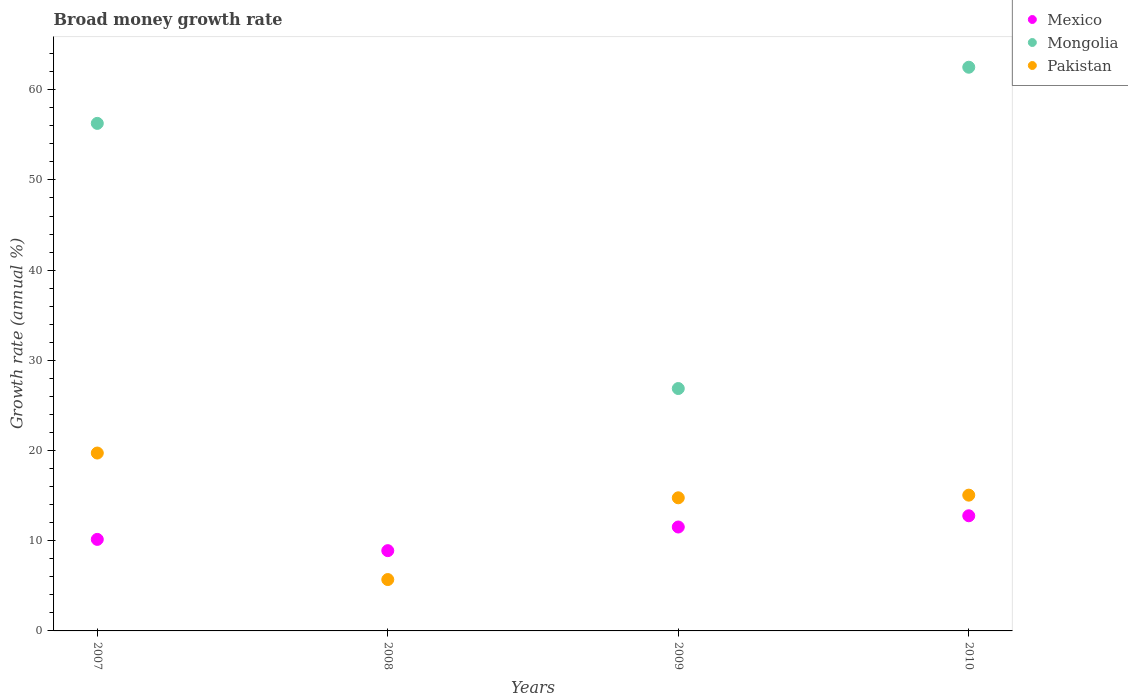How many different coloured dotlines are there?
Offer a terse response. 3. Is the number of dotlines equal to the number of legend labels?
Offer a very short reply. No. What is the growth rate in Pakistan in 2010?
Your answer should be very brief. 15.05. Across all years, what is the maximum growth rate in Pakistan?
Your response must be concise. 19.72. Across all years, what is the minimum growth rate in Pakistan?
Offer a very short reply. 5.69. In which year was the growth rate in Mongolia maximum?
Offer a very short reply. 2010. What is the total growth rate in Mexico in the graph?
Provide a succinct answer. 43.33. What is the difference between the growth rate in Pakistan in 2007 and that in 2008?
Your response must be concise. 14.03. What is the difference between the growth rate in Pakistan in 2010 and the growth rate in Mongolia in 2009?
Offer a very short reply. -11.82. What is the average growth rate in Mongolia per year?
Your answer should be very brief. 36.41. In the year 2010, what is the difference between the growth rate in Mexico and growth rate in Mongolia?
Offer a very short reply. -49.73. What is the ratio of the growth rate in Mongolia in 2009 to that in 2010?
Make the answer very short. 0.43. Is the growth rate in Mexico in 2007 less than that in 2009?
Your answer should be compact. Yes. What is the difference between the highest and the second highest growth rate in Mexico?
Keep it short and to the point. 1.25. What is the difference between the highest and the lowest growth rate in Mongolia?
Provide a succinct answer. 62.5. In how many years, is the growth rate in Mexico greater than the average growth rate in Mexico taken over all years?
Your answer should be compact. 2. Is it the case that in every year, the sum of the growth rate in Mexico and growth rate in Pakistan  is greater than the growth rate in Mongolia?
Offer a very short reply. No. Does the growth rate in Mexico monotonically increase over the years?
Give a very brief answer. No. How many dotlines are there?
Make the answer very short. 3. What is the difference between two consecutive major ticks on the Y-axis?
Your answer should be very brief. 10. Are the values on the major ticks of Y-axis written in scientific E-notation?
Make the answer very short. No. Does the graph contain grids?
Provide a short and direct response. No. How are the legend labels stacked?
Provide a succinct answer. Vertical. What is the title of the graph?
Your answer should be compact. Broad money growth rate. Does "Low & middle income" appear as one of the legend labels in the graph?
Offer a very short reply. No. What is the label or title of the Y-axis?
Ensure brevity in your answer.  Growth rate (annual %). What is the Growth rate (annual %) of Mexico in 2007?
Provide a short and direct response. 10.15. What is the Growth rate (annual %) in Mongolia in 2007?
Give a very brief answer. 56.27. What is the Growth rate (annual %) of Pakistan in 2007?
Make the answer very short. 19.72. What is the Growth rate (annual %) in Mexico in 2008?
Your answer should be very brief. 8.9. What is the Growth rate (annual %) of Mongolia in 2008?
Provide a succinct answer. 0. What is the Growth rate (annual %) in Pakistan in 2008?
Your answer should be very brief. 5.69. What is the Growth rate (annual %) of Mexico in 2009?
Provide a succinct answer. 11.52. What is the Growth rate (annual %) of Mongolia in 2009?
Offer a very short reply. 26.87. What is the Growth rate (annual %) of Pakistan in 2009?
Your answer should be compact. 14.76. What is the Growth rate (annual %) in Mexico in 2010?
Provide a succinct answer. 12.77. What is the Growth rate (annual %) of Mongolia in 2010?
Provide a short and direct response. 62.5. What is the Growth rate (annual %) in Pakistan in 2010?
Offer a very short reply. 15.05. Across all years, what is the maximum Growth rate (annual %) of Mexico?
Your response must be concise. 12.77. Across all years, what is the maximum Growth rate (annual %) of Mongolia?
Provide a succinct answer. 62.5. Across all years, what is the maximum Growth rate (annual %) in Pakistan?
Give a very brief answer. 19.72. Across all years, what is the minimum Growth rate (annual %) in Mexico?
Keep it short and to the point. 8.9. Across all years, what is the minimum Growth rate (annual %) of Pakistan?
Provide a succinct answer. 5.69. What is the total Growth rate (annual %) in Mexico in the graph?
Keep it short and to the point. 43.33. What is the total Growth rate (annual %) of Mongolia in the graph?
Ensure brevity in your answer.  145.64. What is the total Growth rate (annual %) in Pakistan in the graph?
Your answer should be very brief. 55.23. What is the difference between the Growth rate (annual %) in Mexico in 2007 and that in 2008?
Keep it short and to the point. 1.25. What is the difference between the Growth rate (annual %) in Pakistan in 2007 and that in 2008?
Your answer should be compact. 14.03. What is the difference between the Growth rate (annual %) of Mexico in 2007 and that in 2009?
Keep it short and to the point. -1.37. What is the difference between the Growth rate (annual %) in Mongolia in 2007 and that in 2009?
Your answer should be compact. 29.4. What is the difference between the Growth rate (annual %) of Pakistan in 2007 and that in 2009?
Make the answer very short. 4.96. What is the difference between the Growth rate (annual %) of Mexico in 2007 and that in 2010?
Provide a short and direct response. -2.62. What is the difference between the Growth rate (annual %) in Mongolia in 2007 and that in 2010?
Offer a very short reply. -6.23. What is the difference between the Growth rate (annual %) of Pakistan in 2007 and that in 2010?
Offer a terse response. 4.67. What is the difference between the Growth rate (annual %) in Mexico in 2008 and that in 2009?
Give a very brief answer. -2.62. What is the difference between the Growth rate (annual %) of Pakistan in 2008 and that in 2009?
Give a very brief answer. -9.06. What is the difference between the Growth rate (annual %) in Mexico in 2008 and that in 2010?
Your response must be concise. -3.87. What is the difference between the Growth rate (annual %) in Pakistan in 2008 and that in 2010?
Ensure brevity in your answer.  -9.36. What is the difference between the Growth rate (annual %) in Mexico in 2009 and that in 2010?
Offer a terse response. -1.25. What is the difference between the Growth rate (annual %) of Mongolia in 2009 and that in 2010?
Provide a succinct answer. -35.62. What is the difference between the Growth rate (annual %) of Pakistan in 2009 and that in 2010?
Provide a short and direct response. -0.29. What is the difference between the Growth rate (annual %) of Mexico in 2007 and the Growth rate (annual %) of Pakistan in 2008?
Your response must be concise. 4.45. What is the difference between the Growth rate (annual %) of Mongolia in 2007 and the Growth rate (annual %) of Pakistan in 2008?
Your answer should be very brief. 50.58. What is the difference between the Growth rate (annual %) in Mexico in 2007 and the Growth rate (annual %) in Mongolia in 2009?
Provide a succinct answer. -16.73. What is the difference between the Growth rate (annual %) of Mexico in 2007 and the Growth rate (annual %) of Pakistan in 2009?
Keep it short and to the point. -4.61. What is the difference between the Growth rate (annual %) of Mongolia in 2007 and the Growth rate (annual %) of Pakistan in 2009?
Your answer should be very brief. 41.51. What is the difference between the Growth rate (annual %) in Mexico in 2007 and the Growth rate (annual %) in Mongolia in 2010?
Your answer should be compact. -52.35. What is the difference between the Growth rate (annual %) of Mexico in 2007 and the Growth rate (annual %) of Pakistan in 2010?
Provide a succinct answer. -4.91. What is the difference between the Growth rate (annual %) of Mongolia in 2007 and the Growth rate (annual %) of Pakistan in 2010?
Your answer should be compact. 41.22. What is the difference between the Growth rate (annual %) of Mexico in 2008 and the Growth rate (annual %) of Mongolia in 2009?
Give a very brief answer. -17.97. What is the difference between the Growth rate (annual %) in Mexico in 2008 and the Growth rate (annual %) in Pakistan in 2009?
Ensure brevity in your answer.  -5.86. What is the difference between the Growth rate (annual %) of Mexico in 2008 and the Growth rate (annual %) of Mongolia in 2010?
Keep it short and to the point. -53.6. What is the difference between the Growth rate (annual %) in Mexico in 2008 and the Growth rate (annual %) in Pakistan in 2010?
Provide a short and direct response. -6.15. What is the difference between the Growth rate (annual %) in Mexico in 2009 and the Growth rate (annual %) in Mongolia in 2010?
Ensure brevity in your answer.  -50.98. What is the difference between the Growth rate (annual %) of Mexico in 2009 and the Growth rate (annual %) of Pakistan in 2010?
Offer a very short reply. -3.53. What is the difference between the Growth rate (annual %) in Mongolia in 2009 and the Growth rate (annual %) in Pakistan in 2010?
Your answer should be compact. 11.82. What is the average Growth rate (annual %) in Mexico per year?
Provide a succinct answer. 10.83. What is the average Growth rate (annual %) in Mongolia per year?
Provide a succinct answer. 36.41. What is the average Growth rate (annual %) in Pakistan per year?
Give a very brief answer. 13.81. In the year 2007, what is the difference between the Growth rate (annual %) of Mexico and Growth rate (annual %) of Mongolia?
Ensure brevity in your answer.  -46.12. In the year 2007, what is the difference between the Growth rate (annual %) in Mexico and Growth rate (annual %) in Pakistan?
Your response must be concise. -9.57. In the year 2007, what is the difference between the Growth rate (annual %) of Mongolia and Growth rate (annual %) of Pakistan?
Offer a very short reply. 36.55. In the year 2008, what is the difference between the Growth rate (annual %) in Mexico and Growth rate (annual %) in Pakistan?
Offer a very short reply. 3.2. In the year 2009, what is the difference between the Growth rate (annual %) of Mexico and Growth rate (annual %) of Mongolia?
Your response must be concise. -15.35. In the year 2009, what is the difference between the Growth rate (annual %) of Mexico and Growth rate (annual %) of Pakistan?
Ensure brevity in your answer.  -3.24. In the year 2009, what is the difference between the Growth rate (annual %) in Mongolia and Growth rate (annual %) in Pakistan?
Give a very brief answer. 12.11. In the year 2010, what is the difference between the Growth rate (annual %) of Mexico and Growth rate (annual %) of Mongolia?
Your answer should be compact. -49.73. In the year 2010, what is the difference between the Growth rate (annual %) of Mexico and Growth rate (annual %) of Pakistan?
Your answer should be very brief. -2.29. In the year 2010, what is the difference between the Growth rate (annual %) of Mongolia and Growth rate (annual %) of Pakistan?
Offer a terse response. 47.44. What is the ratio of the Growth rate (annual %) in Mexico in 2007 to that in 2008?
Your answer should be very brief. 1.14. What is the ratio of the Growth rate (annual %) in Pakistan in 2007 to that in 2008?
Offer a very short reply. 3.46. What is the ratio of the Growth rate (annual %) in Mexico in 2007 to that in 2009?
Keep it short and to the point. 0.88. What is the ratio of the Growth rate (annual %) of Mongolia in 2007 to that in 2009?
Provide a succinct answer. 2.09. What is the ratio of the Growth rate (annual %) of Pakistan in 2007 to that in 2009?
Your answer should be very brief. 1.34. What is the ratio of the Growth rate (annual %) of Mexico in 2007 to that in 2010?
Your answer should be very brief. 0.79. What is the ratio of the Growth rate (annual %) in Mongolia in 2007 to that in 2010?
Offer a very short reply. 0.9. What is the ratio of the Growth rate (annual %) in Pakistan in 2007 to that in 2010?
Offer a terse response. 1.31. What is the ratio of the Growth rate (annual %) of Mexico in 2008 to that in 2009?
Provide a short and direct response. 0.77. What is the ratio of the Growth rate (annual %) in Pakistan in 2008 to that in 2009?
Offer a very short reply. 0.39. What is the ratio of the Growth rate (annual %) in Mexico in 2008 to that in 2010?
Ensure brevity in your answer.  0.7. What is the ratio of the Growth rate (annual %) of Pakistan in 2008 to that in 2010?
Your answer should be compact. 0.38. What is the ratio of the Growth rate (annual %) in Mexico in 2009 to that in 2010?
Your answer should be compact. 0.9. What is the ratio of the Growth rate (annual %) of Mongolia in 2009 to that in 2010?
Your answer should be compact. 0.43. What is the ratio of the Growth rate (annual %) of Pakistan in 2009 to that in 2010?
Your response must be concise. 0.98. What is the difference between the highest and the second highest Growth rate (annual %) in Mexico?
Your answer should be very brief. 1.25. What is the difference between the highest and the second highest Growth rate (annual %) in Mongolia?
Make the answer very short. 6.23. What is the difference between the highest and the second highest Growth rate (annual %) in Pakistan?
Make the answer very short. 4.67. What is the difference between the highest and the lowest Growth rate (annual %) of Mexico?
Your answer should be compact. 3.87. What is the difference between the highest and the lowest Growth rate (annual %) of Mongolia?
Offer a very short reply. 62.5. What is the difference between the highest and the lowest Growth rate (annual %) of Pakistan?
Give a very brief answer. 14.03. 